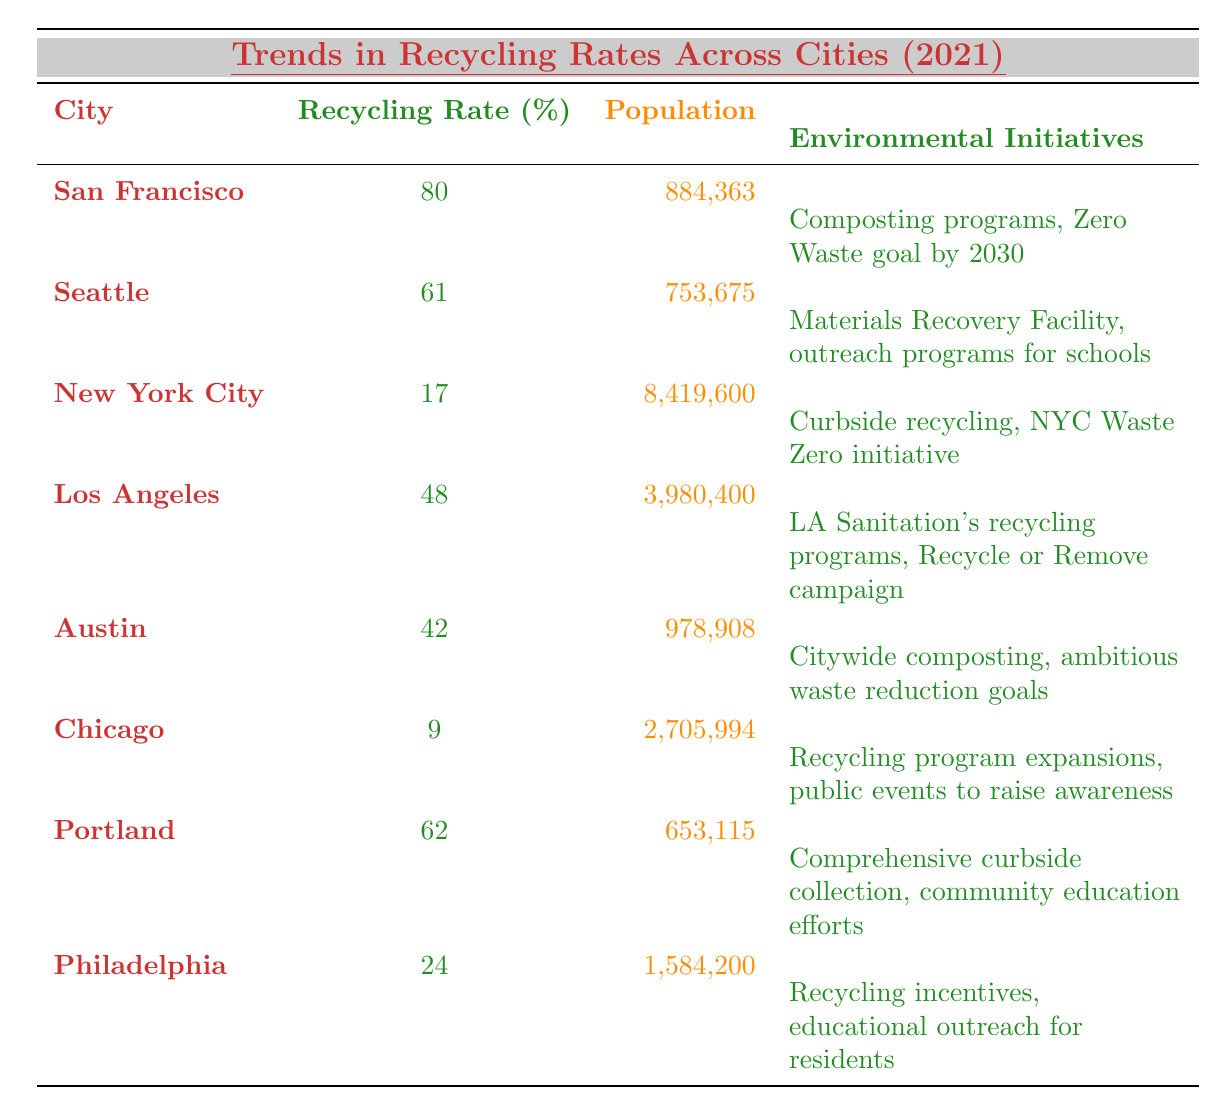What city has the highest recycling rate? San Francisco has the highest recycling rate listed in the table at 80%.
Answer: San Francisco Which city has the lowest recycling rate? Chicago has the lowest recycling rate at 9%.
Answer: Chicago How many people live in Seattle? The population of Seattle is 753,675 as shown in the table.
Answer: 753,675 What is the average recycling rate of the cities listed? First, sum the recycling rates: 80 + 61 + 17 + 48 + 42 + 9 + 62 + 24 = 343. Then, divide by the number of cities (8): 343 / 8 = 42.875.
Answer: 42.875 Does New York City have a higher recycling rate than Austin? New York City has a recycling rate of 17%, while Austin's recycling rate is 42%. Therefore, New York City does not have a higher rate.
Answer: No Which city has a population closest to 900,000? Austin has a population of 978,908, which is the closest to 900,000 when compared to other cities.
Answer: Austin Are the environmental initiatives in San Francisco more ambitious than those in New York City? San Francisco aims for a Zero Waste goal by 2030, while New York City's initiatives are less ambitious in comparison, focusing on curbside recycling.
Answer: Yes How many cities have a recycling rate of 60% or higher? The cities with a recycling rate of 60% or higher are San Francisco (80%) and Portland (62%), totaling 2 cities.
Answer: 2 What is the difference in recycling rates between Portland and Philadelphia? Portland has a recycling rate of 62% and Philadelphia has 24%. The difference is 62 - 24 = 38%.
Answer: 38% Is there any city with a recycling rate below 20%? Yes, New York City (17%) and Chicago (9%) both have recycling rates below 20%.
Answer: Yes 